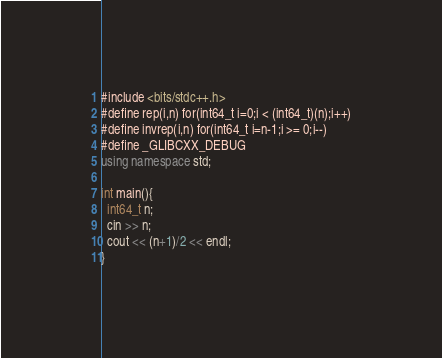<code> <loc_0><loc_0><loc_500><loc_500><_C++_>#include <bits/stdc++.h>
#define rep(i,n) for(int64_t i=0;i < (int64_t)(n);i++)
#define invrep(i,n) for(int64_t i=n-1;i >= 0;i--)
#define _GLIBCXX_DEBUG
using namespace std;

int main(){
  int64_t n;
  cin >> n;
  cout << (n+1)/2 << endl;
}</code> 